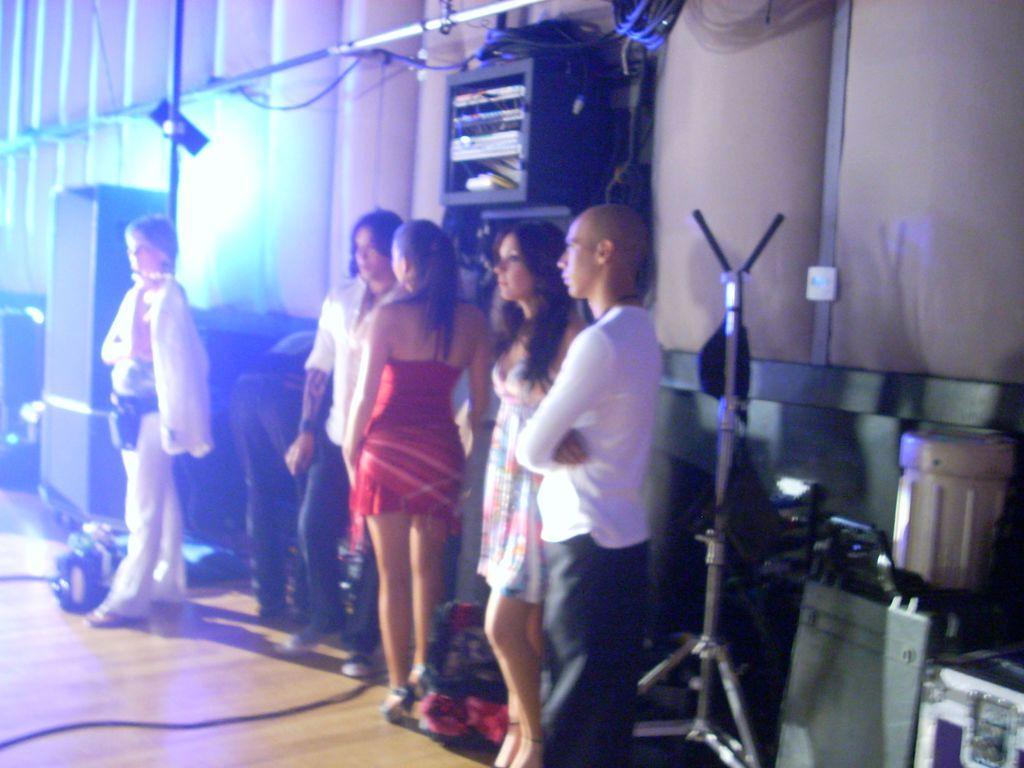Please provide a concise description of this image. In this picture we can see some girls standing and looking on the left side. Behind there is a black color box, hanging on the wall. On the left corner there is a black speaker. In the background we can see the cushion wall. 